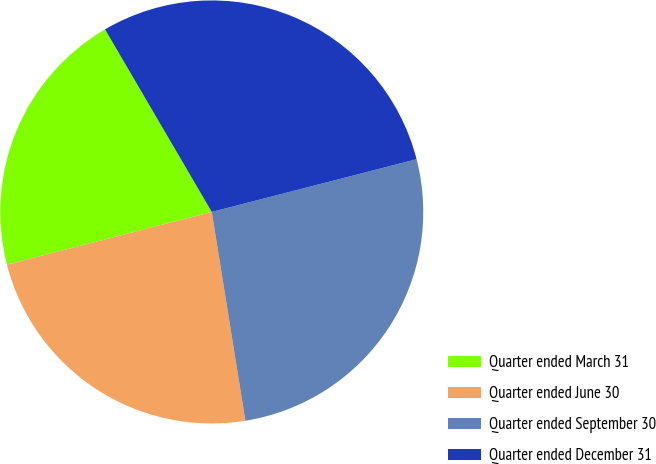<chart> <loc_0><loc_0><loc_500><loc_500><pie_chart><fcel>Quarter ended March 31<fcel>Quarter ended June 30<fcel>Quarter ended September 30<fcel>Quarter ended December 31<nl><fcel>20.59%<fcel>23.53%<fcel>26.47%<fcel>29.41%<nl></chart> 